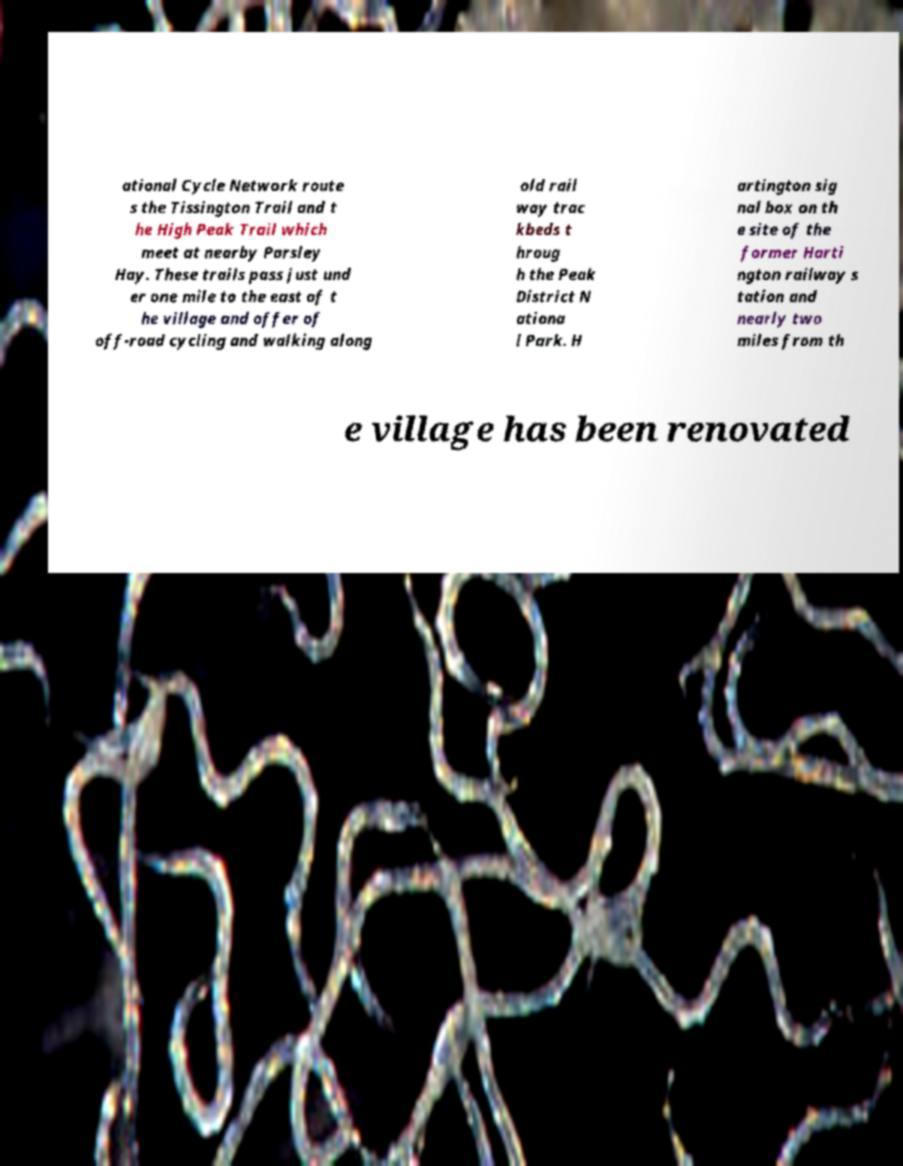Could you extract and type out the text from this image? ational Cycle Network route s the Tissington Trail and t he High Peak Trail which meet at nearby Parsley Hay. These trails pass just und er one mile to the east of t he village and offer of off-road cycling and walking along old rail way trac kbeds t hroug h the Peak District N ationa l Park. H artington sig nal box on th e site of the former Harti ngton railway s tation and nearly two miles from th e village has been renovated 